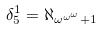<formula> <loc_0><loc_0><loc_500><loc_500>\delta _ { 5 } ^ { 1 } = \aleph _ { \omega ^ { \omega ^ { \omega } } + 1 }</formula> 